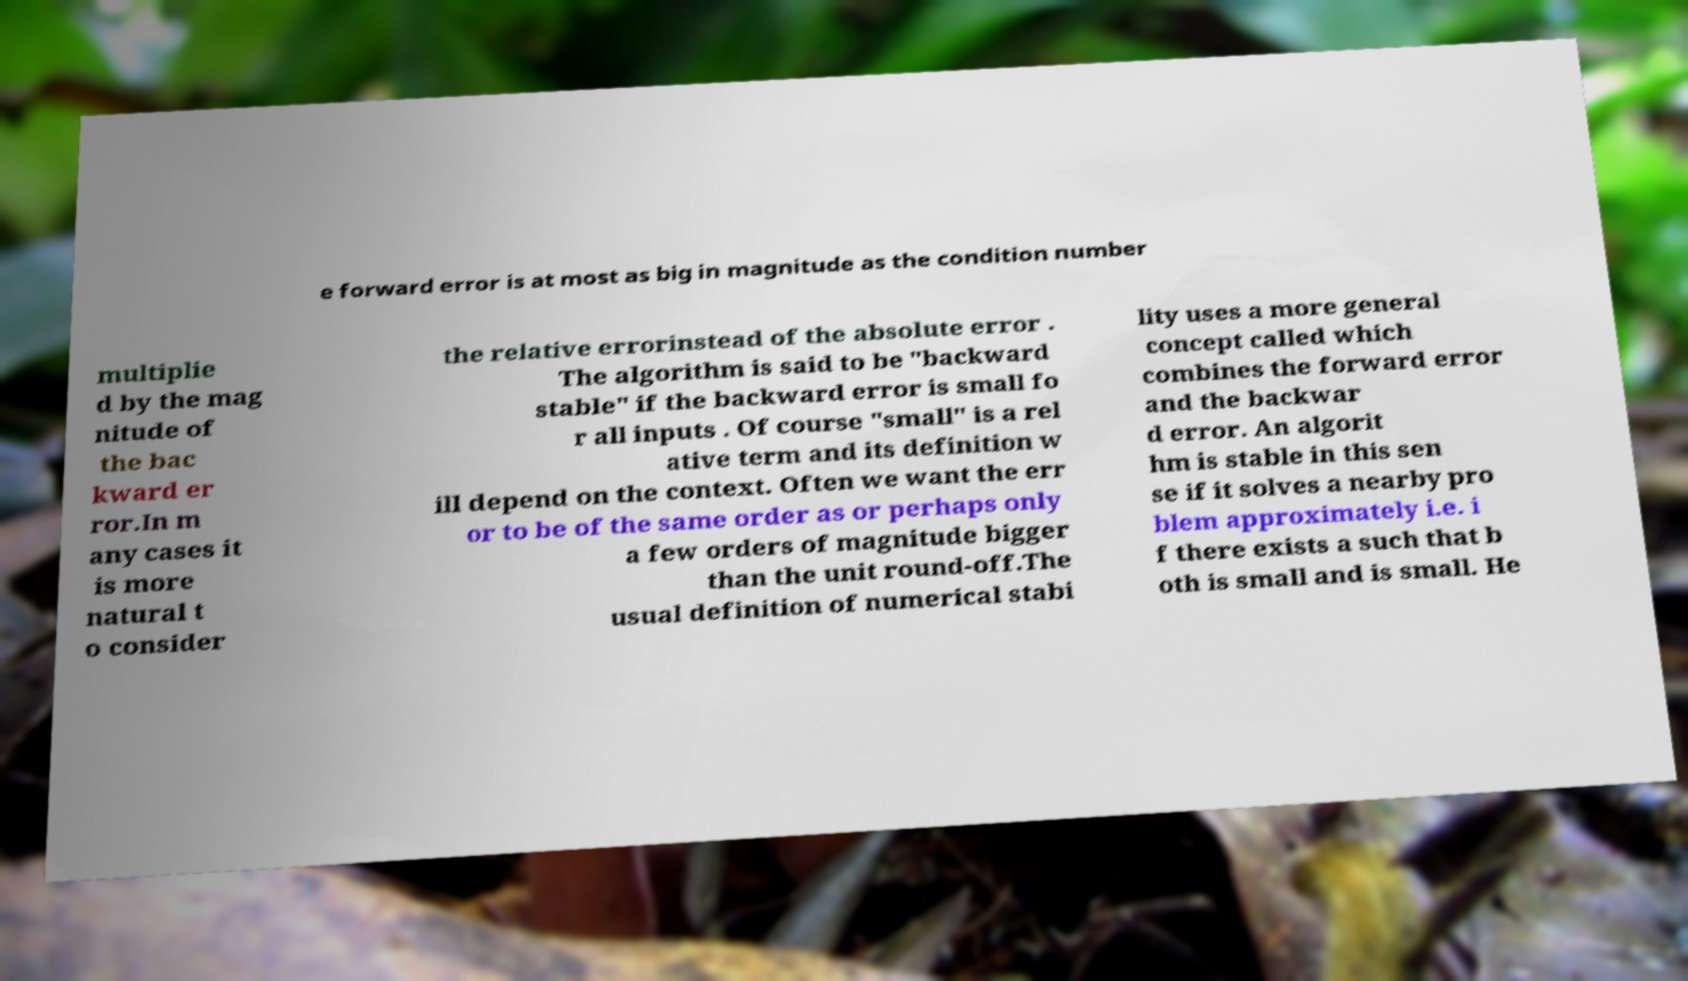There's text embedded in this image that I need extracted. Can you transcribe it verbatim? e forward error is at most as big in magnitude as the condition number multiplie d by the mag nitude of the bac kward er ror.In m any cases it is more natural t o consider the relative errorinstead of the absolute error . The algorithm is said to be "backward stable" if the backward error is small fo r all inputs . Of course "small" is a rel ative term and its definition w ill depend on the context. Often we want the err or to be of the same order as or perhaps only a few orders of magnitude bigger than the unit round-off.The usual definition of numerical stabi lity uses a more general concept called which combines the forward error and the backwar d error. An algorit hm is stable in this sen se if it solves a nearby pro blem approximately i.e. i f there exists a such that b oth is small and is small. He 